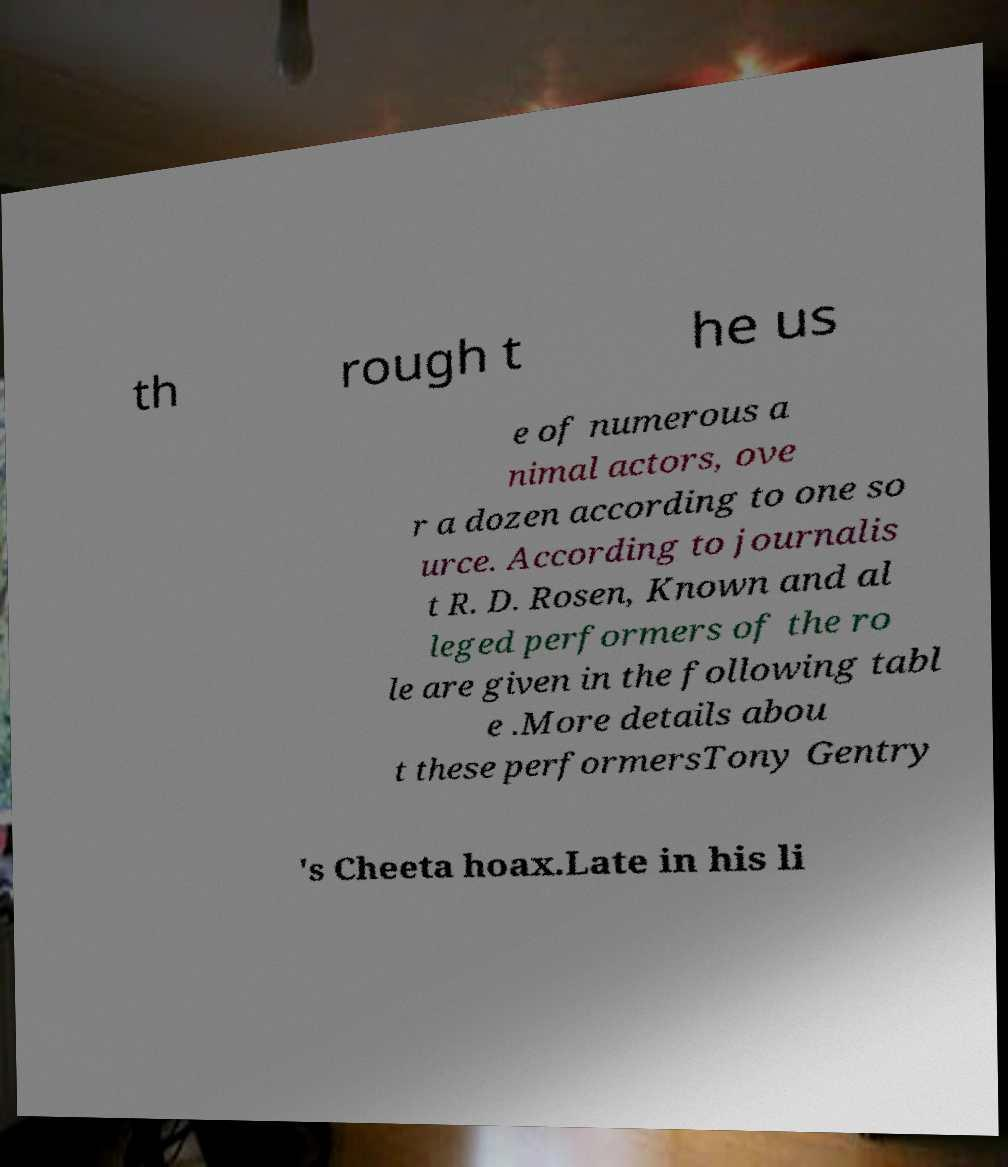I need the written content from this picture converted into text. Can you do that? th rough t he us e of numerous a nimal actors, ove r a dozen according to one so urce. According to journalis t R. D. Rosen, Known and al leged performers of the ro le are given in the following tabl e .More details abou t these performersTony Gentry 's Cheeta hoax.Late in his li 